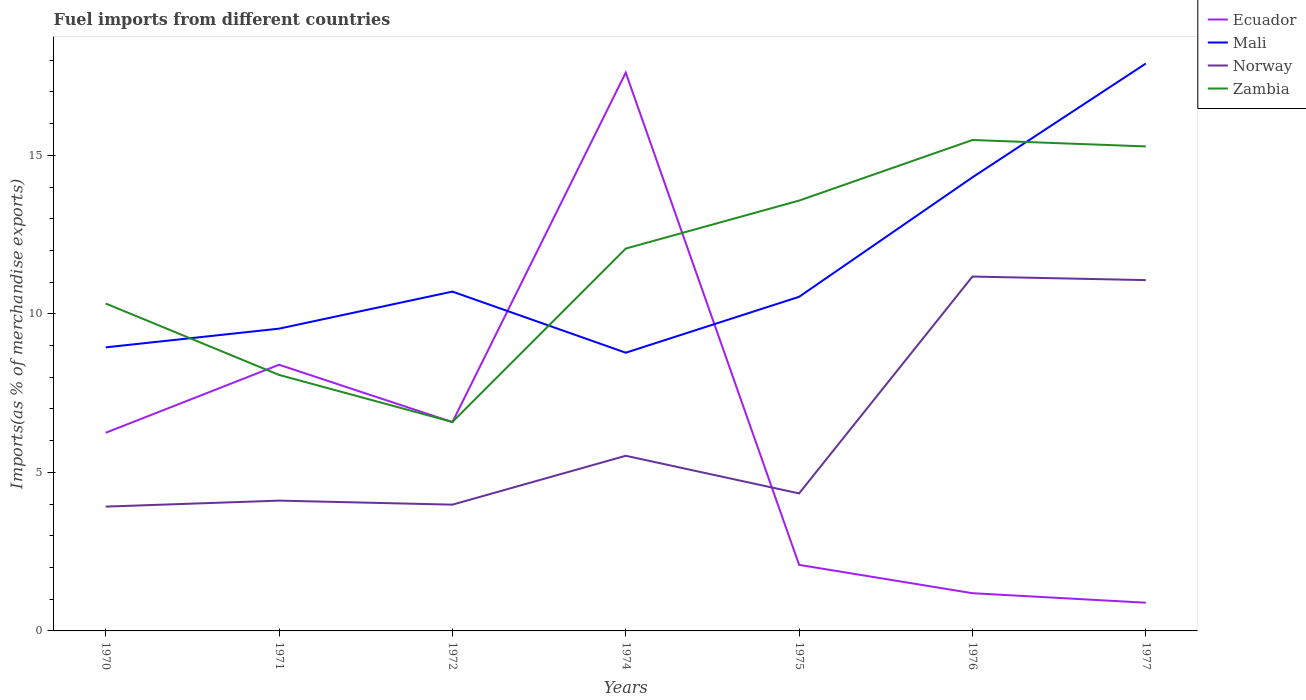Does the line corresponding to Ecuador intersect with the line corresponding to Norway?
Provide a short and direct response. Yes. Is the number of lines equal to the number of legend labels?
Offer a terse response. Yes. Across all years, what is the maximum percentage of imports to different countries in Mali?
Provide a succinct answer. 8.78. In which year was the percentage of imports to different countries in Norway maximum?
Provide a short and direct response. 1970. What is the total percentage of imports to different countries in Norway in the graph?
Offer a very short reply. -6.73. What is the difference between the highest and the second highest percentage of imports to different countries in Mali?
Keep it short and to the point. 9.12. What is the difference between the highest and the lowest percentage of imports to different countries in Norway?
Provide a short and direct response. 2. Are the values on the major ticks of Y-axis written in scientific E-notation?
Keep it short and to the point. No. Does the graph contain grids?
Keep it short and to the point. No. Where does the legend appear in the graph?
Make the answer very short. Top right. How many legend labels are there?
Keep it short and to the point. 4. What is the title of the graph?
Your answer should be very brief. Fuel imports from different countries. Does "Bangladesh" appear as one of the legend labels in the graph?
Make the answer very short. No. What is the label or title of the X-axis?
Provide a short and direct response. Years. What is the label or title of the Y-axis?
Provide a short and direct response. Imports(as % of merchandise exports). What is the Imports(as % of merchandise exports) in Ecuador in 1970?
Your answer should be very brief. 6.25. What is the Imports(as % of merchandise exports) of Mali in 1970?
Your response must be concise. 8.94. What is the Imports(as % of merchandise exports) in Norway in 1970?
Keep it short and to the point. 3.92. What is the Imports(as % of merchandise exports) of Zambia in 1970?
Provide a short and direct response. 10.33. What is the Imports(as % of merchandise exports) of Ecuador in 1971?
Your answer should be very brief. 8.4. What is the Imports(as % of merchandise exports) of Mali in 1971?
Offer a terse response. 9.53. What is the Imports(as % of merchandise exports) of Norway in 1971?
Your response must be concise. 4.11. What is the Imports(as % of merchandise exports) in Zambia in 1971?
Offer a terse response. 8.07. What is the Imports(as % of merchandise exports) in Ecuador in 1972?
Ensure brevity in your answer.  6.59. What is the Imports(as % of merchandise exports) of Mali in 1972?
Give a very brief answer. 10.7. What is the Imports(as % of merchandise exports) of Norway in 1972?
Provide a succinct answer. 3.98. What is the Imports(as % of merchandise exports) in Zambia in 1972?
Your response must be concise. 6.59. What is the Imports(as % of merchandise exports) in Ecuador in 1974?
Make the answer very short. 17.61. What is the Imports(as % of merchandise exports) in Mali in 1974?
Offer a very short reply. 8.78. What is the Imports(as % of merchandise exports) of Norway in 1974?
Offer a very short reply. 5.52. What is the Imports(as % of merchandise exports) of Zambia in 1974?
Ensure brevity in your answer.  12.06. What is the Imports(as % of merchandise exports) of Ecuador in 1975?
Provide a short and direct response. 2.08. What is the Imports(as % of merchandise exports) of Mali in 1975?
Give a very brief answer. 10.54. What is the Imports(as % of merchandise exports) of Norway in 1975?
Ensure brevity in your answer.  4.34. What is the Imports(as % of merchandise exports) in Zambia in 1975?
Provide a succinct answer. 13.57. What is the Imports(as % of merchandise exports) of Ecuador in 1976?
Make the answer very short. 1.19. What is the Imports(as % of merchandise exports) in Mali in 1976?
Offer a very short reply. 14.31. What is the Imports(as % of merchandise exports) of Norway in 1976?
Provide a short and direct response. 11.18. What is the Imports(as % of merchandise exports) of Zambia in 1976?
Ensure brevity in your answer.  15.48. What is the Imports(as % of merchandise exports) in Ecuador in 1977?
Your answer should be compact. 0.89. What is the Imports(as % of merchandise exports) of Mali in 1977?
Provide a succinct answer. 17.9. What is the Imports(as % of merchandise exports) of Norway in 1977?
Provide a succinct answer. 11.06. What is the Imports(as % of merchandise exports) of Zambia in 1977?
Your answer should be compact. 15.28. Across all years, what is the maximum Imports(as % of merchandise exports) in Ecuador?
Your answer should be compact. 17.61. Across all years, what is the maximum Imports(as % of merchandise exports) of Mali?
Give a very brief answer. 17.9. Across all years, what is the maximum Imports(as % of merchandise exports) of Norway?
Give a very brief answer. 11.18. Across all years, what is the maximum Imports(as % of merchandise exports) in Zambia?
Your answer should be compact. 15.48. Across all years, what is the minimum Imports(as % of merchandise exports) in Ecuador?
Keep it short and to the point. 0.89. Across all years, what is the minimum Imports(as % of merchandise exports) in Mali?
Give a very brief answer. 8.78. Across all years, what is the minimum Imports(as % of merchandise exports) in Norway?
Your answer should be compact. 3.92. Across all years, what is the minimum Imports(as % of merchandise exports) of Zambia?
Ensure brevity in your answer.  6.59. What is the total Imports(as % of merchandise exports) of Ecuador in the graph?
Your answer should be very brief. 43. What is the total Imports(as % of merchandise exports) in Mali in the graph?
Provide a succinct answer. 80.7. What is the total Imports(as % of merchandise exports) in Norway in the graph?
Provide a succinct answer. 44.12. What is the total Imports(as % of merchandise exports) of Zambia in the graph?
Offer a very short reply. 81.39. What is the difference between the Imports(as % of merchandise exports) of Ecuador in 1970 and that in 1971?
Provide a succinct answer. -2.15. What is the difference between the Imports(as % of merchandise exports) of Mali in 1970 and that in 1971?
Offer a terse response. -0.59. What is the difference between the Imports(as % of merchandise exports) of Norway in 1970 and that in 1971?
Offer a very short reply. -0.19. What is the difference between the Imports(as % of merchandise exports) of Zambia in 1970 and that in 1971?
Your answer should be compact. 2.25. What is the difference between the Imports(as % of merchandise exports) in Ecuador in 1970 and that in 1972?
Keep it short and to the point. -0.34. What is the difference between the Imports(as % of merchandise exports) in Mali in 1970 and that in 1972?
Provide a short and direct response. -1.76. What is the difference between the Imports(as % of merchandise exports) of Norway in 1970 and that in 1972?
Provide a succinct answer. -0.06. What is the difference between the Imports(as % of merchandise exports) in Zambia in 1970 and that in 1972?
Offer a very short reply. 3.74. What is the difference between the Imports(as % of merchandise exports) in Ecuador in 1970 and that in 1974?
Your response must be concise. -11.36. What is the difference between the Imports(as % of merchandise exports) of Mali in 1970 and that in 1974?
Your answer should be compact. 0.17. What is the difference between the Imports(as % of merchandise exports) in Norway in 1970 and that in 1974?
Make the answer very short. -1.6. What is the difference between the Imports(as % of merchandise exports) in Zambia in 1970 and that in 1974?
Offer a very short reply. -1.73. What is the difference between the Imports(as % of merchandise exports) of Ecuador in 1970 and that in 1975?
Ensure brevity in your answer.  4.17. What is the difference between the Imports(as % of merchandise exports) in Mali in 1970 and that in 1975?
Your answer should be compact. -1.59. What is the difference between the Imports(as % of merchandise exports) in Norway in 1970 and that in 1975?
Your answer should be compact. -0.42. What is the difference between the Imports(as % of merchandise exports) of Zambia in 1970 and that in 1975?
Give a very brief answer. -3.25. What is the difference between the Imports(as % of merchandise exports) of Ecuador in 1970 and that in 1976?
Give a very brief answer. 5.06. What is the difference between the Imports(as % of merchandise exports) in Mali in 1970 and that in 1976?
Provide a succinct answer. -5.36. What is the difference between the Imports(as % of merchandise exports) of Norway in 1970 and that in 1976?
Give a very brief answer. -7.26. What is the difference between the Imports(as % of merchandise exports) of Zambia in 1970 and that in 1976?
Your response must be concise. -5.16. What is the difference between the Imports(as % of merchandise exports) of Ecuador in 1970 and that in 1977?
Your answer should be very brief. 5.36. What is the difference between the Imports(as % of merchandise exports) of Mali in 1970 and that in 1977?
Your answer should be very brief. -8.95. What is the difference between the Imports(as % of merchandise exports) of Norway in 1970 and that in 1977?
Your answer should be compact. -7.14. What is the difference between the Imports(as % of merchandise exports) of Zambia in 1970 and that in 1977?
Give a very brief answer. -4.96. What is the difference between the Imports(as % of merchandise exports) of Ecuador in 1971 and that in 1972?
Keep it short and to the point. 1.81. What is the difference between the Imports(as % of merchandise exports) in Mali in 1971 and that in 1972?
Give a very brief answer. -1.17. What is the difference between the Imports(as % of merchandise exports) of Norway in 1971 and that in 1972?
Your answer should be compact. 0.13. What is the difference between the Imports(as % of merchandise exports) of Zambia in 1971 and that in 1972?
Ensure brevity in your answer.  1.48. What is the difference between the Imports(as % of merchandise exports) of Ecuador in 1971 and that in 1974?
Provide a succinct answer. -9.21. What is the difference between the Imports(as % of merchandise exports) of Mali in 1971 and that in 1974?
Give a very brief answer. 0.76. What is the difference between the Imports(as % of merchandise exports) in Norway in 1971 and that in 1974?
Your answer should be very brief. -1.41. What is the difference between the Imports(as % of merchandise exports) in Zambia in 1971 and that in 1974?
Keep it short and to the point. -3.98. What is the difference between the Imports(as % of merchandise exports) in Ecuador in 1971 and that in 1975?
Your answer should be very brief. 6.31. What is the difference between the Imports(as % of merchandise exports) in Mali in 1971 and that in 1975?
Your answer should be compact. -1. What is the difference between the Imports(as % of merchandise exports) of Norway in 1971 and that in 1975?
Provide a short and direct response. -0.23. What is the difference between the Imports(as % of merchandise exports) of Zambia in 1971 and that in 1975?
Offer a terse response. -5.5. What is the difference between the Imports(as % of merchandise exports) of Ecuador in 1971 and that in 1976?
Your answer should be very brief. 7.21. What is the difference between the Imports(as % of merchandise exports) in Mali in 1971 and that in 1976?
Provide a short and direct response. -4.77. What is the difference between the Imports(as % of merchandise exports) of Norway in 1971 and that in 1976?
Provide a short and direct response. -7.07. What is the difference between the Imports(as % of merchandise exports) of Zambia in 1971 and that in 1976?
Your answer should be compact. -7.41. What is the difference between the Imports(as % of merchandise exports) of Ecuador in 1971 and that in 1977?
Offer a terse response. 7.51. What is the difference between the Imports(as % of merchandise exports) of Mali in 1971 and that in 1977?
Make the answer very short. -8.36. What is the difference between the Imports(as % of merchandise exports) of Norway in 1971 and that in 1977?
Offer a very short reply. -6.96. What is the difference between the Imports(as % of merchandise exports) in Zambia in 1971 and that in 1977?
Your answer should be compact. -7.21. What is the difference between the Imports(as % of merchandise exports) of Ecuador in 1972 and that in 1974?
Make the answer very short. -11.02. What is the difference between the Imports(as % of merchandise exports) of Mali in 1972 and that in 1974?
Your answer should be compact. 1.93. What is the difference between the Imports(as % of merchandise exports) of Norway in 1972 and that in 1974?
Your answer should be very brief. -1.54. What is the difference between the Imports(as % of merchandise exports) in Zambia in 1972 and that in 1974?
Make the answer very short. -5.47. What is the difference between the Imports(as % of merchandise exports) in Ecuador in 1972 and that in 1975?
Your answer should be very brief. 4.5. What is the difference between the Imports(as % of merchandise exports) in Mali in 1972 and that in 1975?
Your response must be concise. 0.17. What is the difference between the Imports(as % of merchandise exports) of Norway in 1972 and that in 1975?
Your response must be concise. -0.35. What is the difference between the Imports(as % of merchandise exports) of Zambia in 1972 and that in 1975?
Ensure brevity in your answer.  -6.98. What is the difference between the Imports(as % of merchandise exports) of Ecuador in 1972 and that in 1976?
Ensure brevity in your answer.  5.4. What is the difference between the Imports(as % of merchandise exports) of Mali in 1972 and that in 1976?
Provide a short and direct response. -3.6. What is the difference between the Imports(as % of merchandise exports) of Norway in 1972 and that in 1976?
Give a very brief answer. -7.2. What is the difference between the Imports(as % of merchandise exports) in Zambia in 1972 and that in 1976?
Provide a succinct answer. -8.89. What is the difference between the Imports(as % of merchandise exports) in Ecuador in 1972 and that in 1977?
Your response must be concise. 5.7. What is the difference between the Imports(as % of merchandise exports) in Mali in 1972 and that in 1977?
Ensure brevity in your answer.  -7.19. What is the difference between the Imports(as % of merchandise exports) of Norway in 1972 and that in 1977?
Ensure brevity in your answer.  -7.08. What is the difference between the Imports(as % of merchandise exports) in Zambia in 1972 and that in 1977?
Your answer should be very brief. -8.69. What is the difference between the Imports(as % of merchandise exports) in Ecuador in 1974 and that in 1975?
Keep it short and to the point. 15.53. What is the difference between the Imports(as % of merchandise exports) in Mali in 1974 and that in 1975?
Your answer should be very brief. -1.76. What is the difference between the Imports(as % of merchandise exports) of Norway in 1974 and that in 1975?
Offer a terse response. 1.19. What is the difference between the Imports(as % of merchandise exports) in Zambia in 1974 and that in 1975?
Your answer should be very brief. -1.51. What is the difference between the Imports(as % of merchandise exports) of Ecuador in 1974 and that in 1976?
Make the answer very short. 16.42. What is the difference between the Imports(as % of merchandise exports) in Mali in 1974 and that in 1976?
Your answer should be very brief. -5.53. What is the difference between the Imports(as % of merchandise exports) of Norway in 1974 and that in 1976?
Provide a short and direct response. -5.65. What is the difference between the Imports(as % of merchandise exports) in Zambia in 1974 and that in 1976?
Ensure brevity in your answer.  -3.42. What is the difference between the Imports(as % of merchandise exports) of Ecuador in 1974 and that in 1977?
Give a very brief answer. 16.72. What is the difference between the Imports(as % of merchandise exports) of Mali in 1974 and that in 1977?
Offer a terse response. -9.12. What is the difference between the Imports(as % of merchandise exports) in Norway in 1974 and that in 1977?
Keep it short and to the point. -5.54. What is the difference between the Imports(as % of merchandise exports) in Zambia in 1974 and that in 1977?
Offer a terse response. -3.22. What is the difference between the Imports(as % of merchandise exports) in Ecuador in 1975 and that in 1976?
Make the answer very short. 0.89. What is the difference between the Imports(as % of merchandise exports) in Mali in 1975 and that in 1976?
Provide a short and direct response. -3.77. What is the difference between the Imports(as % of merchandise exports) in Norway in 1975 and that in 1976?
Offer a very short reply. -6.84. What is the difference between the Imports(as % of merchandise exports) of Zambia in 1975 and that in 1976?
Offer a very short reply. -1.91. What is the difference between the Imports(as % of merchandise exports) in Ecuador in 1975 and that in 1977?
Your answer should be very brief. 1.19. What is the difference between the Imports(as % of merchandise exports) in Mali in 1975 and that in 1977?
Your response must be concise. -7.36. What is the difference between the Imports(as % of merchandise exports) of Norway in 1975 and that in 1977?
Provide a short and direct response. -6.73. What is the difference between the Imports(as % of merchandise exports) of Zambia in 1975 and that in 1977?
Provide a succinct answer. -1.71. What is the difference between the Imports(as % of merchandise exports) in Ecuador in 1976 and that in 1977?
Your answer should be compact. 0.3. What is the difference between the Imports(as % of merchandise exports) in Mali in 1976 and that in 1977?
Offer a very short reply. -3.59. What is the difference between the Imports(as % of merchandise exports) of Norway in 1976 and that in 1977?
Your answer should be very brief. 0.11. What is the difference between the Imports(as % of merchandise exports) of Zambia in 1976 and that in 1977?
Offer a terse response. 0.2. What is the difference between the Imports(as % of merchandise exports) in Ecuador in 1970 and the Imports(as % of merchandise exports) in Mali in 1971?
Provide a succinct answer. -3.28. What is the difference between the Imports(as % of merchandise exports) of Ecuador in 1970 and the Imports(as % of merchandise exports) of Norway in 1971?
Provide a succinct answer. 2.14. What is the difference between the Imports(as % of merchandise exports) of Ecuador in 1970 and the Imports(as % of merchandise exports) of Zambia in 1971?
Keep it short and to the point. -1.82. What is the difference between the Imports(as % of merchandise exports) of Mali in 1970 and the Imports(as % of merchandise exports) of Norway in 1971?
Your response must be concise. 4.83. What is the difference between the Imports(as % of merchandise exports) in Mali in 1970 and the Imports(as % of merchandise exports) in Zambia in 1971?
Offer a very short reply. 0.87. What is the difference between the Imports(as % of merchandise exports) of Norway in 1970 and the Imports(as % of merchandise exports) of Zambia in 1971?
Keep it short and to the point. -4.15. What is the difference between the Imports(as % of merchandise exports) of Ecuador in 1970 and the Imports(as % of merchandise exports) of Mali in 1972?
Offer a very short reply. -4.45. What is the difference between the Imports(as % of merchandise exports) of Ecuador in 1970 and the Imports(as % of merchandise exports) of Norway in 1972?
Make the answer very short. 2.27. What is the difference between the Imports(as % of merchandise exports) of Ecuador in 1970 and the Imports(as % of merchandise exports) of Zambia in 1972?
Provide a succinct answer. -0.34. What is the difference between the Imports(as % of merchandise exports) in Mali in 1970 and the Imports(as % of merchandise exports) in Norway in 1972?
Make the answer very short. 4.96. What is the difference between the Imports(as % of merchandise exports) in Mali in 1970 and the Imports(as % of merchandise exports) in Zambia in 1972?
Make the answer very short. 2.35. What is the difference between the Imports(as % of merchandise exports) in Norway in 1970 and the Imports(as % of merchandise exports) in Zambia in 1972?
Give a very brief answer. -2.67. What is the difference between the Imports(as % of merchandise exports) of Ecuador in 1970 and the Imports(as % of merchandise exports) of Mali in 1974?
Offer a very short reply. -2.52. What is the difference between the Imports(as % of merchandise exports) of Ecuador in 1970 and the Imports(as % of merchandise exports) of Norway in 1974?
Make the answer very short. 0.73. What is the difference between the Imports(as % of merchandise exports) of Ecuador in 1970 and the Imports(as % of merchandise exports) of Zambia in 1974?
Your answer should be compact. -5.81. What is the difference between the Imports(as % of merchandise exports) of Mali in 1970 and the Imports(as % of merchandise exports) of Norway in 1974?
Keep it short and to the point. 3.42. What is the difference between the Imports(as % of merchandise exports) of Mali in 1970 and the Imports(as % of merchandise exports) of Zambia in 1974?
Offer a terse response. -3.12. What is the difference between the Imports(as % of merchandise exports) in Norway in 1970 and the Imports(as % of merchandise exports) in Zambia in 1974?
Your answer should be very brief. -8.14. What is the difference between the Imports(as % of merchandise exports) in Ecuador in 1970 and the Imports(as % of merchandise exports) in Mali in 1975?
Provide a succinct answer. -4.29. What is the difference between the Imports(as % of merchandise exports) in Ecuador in 1970 and the Imports(as % of merchandise exports) in Norway in 1975?
Provide a short and direct response. 1.91. What is the difference between the Imports(as % of merchandise exports) in Ecuador in 1970 and the Imports(as % of merchandise exports) in Zambia in 1975?
Keep it short and to the point. -7.32. What is the difference between the Imports(as % of merchandise exports) of Mali in 1970 and the Imports(as % of merchandise exports) of Norway in 1975?
Make the answer very short. 4.61. What is the difference between the Imports(as % of merchandise exports) of Mali in 1970 and the Imports(as % of merchandise exports) of Zambia in 1975?
Ensure brevity in your answer.  -4.63. What is the difference between the Imports(as % of merchandise exports) of Norway in 1970 and the Imports(as % of merchandise exports) of Zambia in 1975?
Provide a short and direct response. -9.65. What is the difference between the Imports(as % of merchandise exports) of Ecuador in 1970 and the Imports(as % of merchandise exports) of Mali in 1976?
Give a very brief answer. -8.06. What is the difference between the Imports(as % of merchandise exports) in Ecuador in 1970 and the Imports(as % of merchandise exports) in Norway in 1976?
Your response must be concise. -4.93. What is the difference between the Imports(as % of merchandise exports) in Ecuador in 1970 and the Imports(as % of merchandise exports) in Zambia in 1976?
Keep it short and to the point. -9.23. What is the difference between the Imports(as % of merchandise exports) in Mali in 1970 and the Imports(as % of merchandise exports) in Norway in 1976?
Keep it short and to the point. -2.23. What is the difference between the Imports(as % of merchandise exports) in Mali in 1970 and the Imports(as % of merchandise exports) in Zambia in 1976?
Offer a terse response. -6.54. What is the difference between the Imports(as % of merchandise exports) of Norway in 1970 and the Imports(as % of merchandise exports) of Zambia in 1976?
Your answer should be compact. -11.56. What is the difference between the Imports(as % of merchandise exports) in Ecuador in 1970 and the Imports(as % of merchandise exports) in Mali in 1977?
Your answer should be very brief. -11.65. What is the difference between the Imports(as % of merchandise exports) of Ecuador in 1970 and the Imports(as % of merchandise exports) of Norway in 1977?
Give a very brief answer. -4.81. What is the difference between the Imports(as % of merchandise exports) of Ecuador in 1970 and the Imports(as % of merchandise exports) of Zambia in 1977?
Keep it short and to the point. -9.03. What is the difference between the Imports(as % of merchandise exports) of Mali in 1970 and the Imports(as % of merchandise exports) of Norway in 1977?
Make the answer very short. -2.12. What is the difference between the Imports(as % of merchandise exports) in Mali in 1970 and the Imports(as % of merchandise exports) in Zambia in 1977?
Provide a short and direct response. -6.34. What is the difference between the Imports(as % of merchandise exports) in Norway in 1970 and the Imports(as % of merchandise exports) in Zambia in 1977?
Ensure brevity in your answer.  -11.36. What is the difference between the Imports(as % of merchandise exports) in Ecuador in 1971 and the Imports(as % of merchandise exports) in Mali in 1972?
Provide a succinct answer. -2.31. What is the difference between the Imports(as % of merchandise exports) of Ecuador in 1971 and the Imports(as % of merchandise exports) of Norway in 1972?
Provide a short and direct response. 4.41. What is the difference between the Imports(as % of merchandise exports) in Ecuador in 1971 and the Imports(as % of merchandise exports) in Zambia in 1972?
Provide a short and direct response. 1.81. What is the difference between the Imports(as % of merchandise exports) of Mali in 1971 and the Imports(as % of merchandise exports) of Norway in 1972?
Offer a very short reply. 5.55. What is the difference between the Imports(as % of merchandise exports) of Mali in 1971 and the Imports(as % of merchandise exports) of Zambia in 1972?
Offer a very short reply. 2.94. What is the difference between the Imports(as % of merchandise exports) of Norway in 1971 and the Imports(as % of merchandise exports) of Zambia in 1972?
Your response must be concise. -2.48. What is the difference between the Imports(as % of merchandise exports) of Ecuador in 1971 and the Imports(as % of merchandise exports) of Mali in 1974?
Provide a succinct answer. -0.38. What is the difference between the Imports(as % of merchandise exports) in Ecuador in 1971 and the Imports(as % of merchandise exports) in Norway in 1974?
Offer a terse response. 2.87. What is the difference between the Imports(as % of merchandise exports) of Ecuador in 1971 and the Imports(as % of merchandise exports) of Zambia in 1974?
Your answer should be compact. -3.66. What is the difference between the Imports(as % of merchandise exports) of Mali in 1971 and the Imports(as % of merchandise exports) of Norway in 1974?
Give a very brief answer. 4.01. What is the difference between the Imports(as % of merchandise exports) of Mali in 1971 and the Imports(as % of merchandise exports) of Zambia in 1974?
Give a very brief answer. -2.53. What is the difference between the Imports(as % of merchandise exports) of Norway in 1971 and the Imports(as % of merchandise exports) of Zambia in 1974?
Your answer should be compact. -7.95. What is the difference between the Imports(as % of merchandise exports) in Ecuador in 1971 and the Imports(as % of merchandise exports) in Mali in 1975?
Your response must be concise. -2.14. What is the difference between the Imports(as % of merchandise exports) in Ecuador in 1971 and the Imports(as % of merchandise exports) in Norway in 1975?
Give a very brief answer. 4.06. What is the difference between the Imports(as % of merchandise exports) of Ecuador in 1971 and the Imports(as % of merchandise exports) of Zambia in 1975?
Your answer should be compact. -5.18. What is the difference between the Imports(as % of merchandise exports) of Mali in 1971 and the Imports(as % of merchandise exports) of Norway in 1975?
Your answer should be very brief. 5.2. What is the difference between the Imports(as % of merchandise exports) in Mali in 1971 and the Imports(as % of merchandise exports) in Zambia in 1975?
Offer a terse response. -4.04. What is the difference between the Imports(as % of merchandise exports) in Norway in 1971 and the Imports(as % of merchandise exports) in Zambia in 1975?
Provide a short and direct response. -9.46. What is the difference between the Imports(as % of merchandise exports) of Ecuador in 1971 and the Imports(as % of merchandise exports) of Mali in 1976?
Offer a very short reply. -5.91. What is the difference between the Imports(as % of merchandise exports) in Ecuador in 1971 and the Imports(as % of merchandise exports) in Norway in 1976?
Provide a succinct answer. -2.78. What is the difference between the Imports(as % of merchandise exports) of Ecuador in 1971 and the Imports(as % of merchandise exports) of Zambia in 1976?
Your response must be concise. -7.09. What is the difference between the Imports(as % of merchandise exports) of Mali in 1971 and the Imports(as % of merchandise exports) of Norway in 1976?
Ensure brevity in your answer.  -1.64. What is the difference between the Imports(as % of merchandise exports) in Mali in 1971 and the Imports(as % of merchandise exports) in Zambia in 1976?
Make the answer very short. -5.95. What is the difference between the Imports(as % of merchandise exports) of Norway in 1971 and the Imports(as % of merchandise exports) of Zambia in 1976?
Ensure brevity in your answer.  -11.38. What is the difference between the Imports(as % of merchandise exports) in Ecuador in 1971 and the Imports(as % of merchandise exports) in Mali in 1977?
Your response must be concise. -9.5. What is the difference between the Imports(as % of merchandise exports) of Ecuador in 1971 and the Imports(as % of merchandise exports) of Norway in 1977?
Make the answer very short. -2.67. What is the difference between the Imports(as % of merchandise exports) of Ecuador in 1971 and the Imports(as % of merchandise exports) of Zambia in 1977?
Offer a terse response. -6.89. What is the difference between the Imports(as % of merchandise exports) in Mali in 1971 and the Imports(as % of merchandise exports) in Norway in 1977?
Offer a very short reply. -1.53. What is the difference between the Imports(as % of merchandise exports) of Mali in 1971 and the Imports(as % of merchandise exports) of Zambia in 1977?
Provide a short and direct response. -5.75. What is the difference between the Imports(as % of merchandise exports) in Norway in 1971 and the Imports(as % of merchandise exports) in Zambia in 1977?
Keep it short and to the point. -11.17. What is the difference between the Imports(as % of merchandise exports) in Ecuador in 1972 and the Imports(as % of merchandise exports) in Mali in 1974?
Offer a terse response. -2.19. What is the difference between the Imports(as % of merchandise exports) of Ecuador in 1972 and the Imports(as % of merchandise exports) of Norway in 1974?
Give a very brief answer. 1.06. What is the difference between the Imports(as % of merchandise exports) of Ecuador in 1972 and the Imports(as % of merchandise exports) of Zambia in 1974?
Keep it short and to the point. -5.47. What is the difference between the Imports(as % of merchandise exports) of Mali in 1972 and the Imports(as % of merchandise exports) of Norway in 1974?
Make the answer very short. 5.18. What is the difference between the Imports(as % of merchandise exports) in Mali in 1972 and the Imports(as % of merchandise exports) in Zambia in 1974?
Offer a terse response. -1.36. What is the difference between the Imports(as % of merchandise exports) of Norway in 1972 and the Imports(as % of merchandise exports) of Zambia in 1974?
Ensure brevity in your answer.  -8.08. What is the difference between the Imports(as % of merchandise exports) of Ecuador in 1972 and the Imports(as % of merchandise exports) of Mali in 1975?
Keep it short and to the point. -3.95. What is the difference between the Imports(as % of merchandise exports) in Ecuador in 1972 and the Imports(as % of merchandise exports) in Norway in 1975?
Offer a terse response. 2.25. What is the difference between the Imports(as % of merchandise exports) of Ecuador in 1972 and the Imports(as % of merchandise exports) of Zambia in 1975?
Keep it short and to the point. -6.99. What is the difference between the Imports(as % of merchandise exports) in Mali in 1972 and the Imports(as % of merchandise exports) in Norway in 1975?
Offer a very short reply. 6.37. What is the difference between the Imports(as % of merchandise exports) in Mali in 1972 and the Imports(as % of merchandise exports) in Zambia in 1975?
Your answer should be very brief. -2.87. What is the difference between the Imports(as % of merchandise exports) in Norway in 1972 and the Imports(as % of merchandise exports) in Zambia in 1975?
Provide a succinct answer. -9.59. What is the difference between the Imports(as % of merchandise exports) of Ecuador in 1972 and the Imports(as % of merchandise exports) of Mali in 1976?
Provide a short and direct response. -7.72. What is the difference between the Imports(as % of merchandise exports) in Ecuador in 1972 and the Imports(as % of merchandise exports) in Norway in 1976?
Make the answer very short. -4.59. What is the difference between the Imports(as % of merchandise exports) of Ecuador in 1972 and the Imports(as % of merchandise exports) of Zambia in 1976?
Offer a very short reply. -8.9. What is the difference between the Imports(as % of merchandise exports) of Mali in 1972 and the Imports(as % of merchandise exports) of Norway in 1976?
Provide a succinct answer. -0.47. What is the difference between the Imports(as % of merchandise exports) of Mali in 1972 and the Imports(as % of merchandise exports) of Zambia in 1976?
Your answer should be very brief. -4.78. What is the difference between the Imports(as % of merchandise exports) in Norway in 1972 and the Imports(as % of merchandise exports) in Zambia in 1976?
Your answer should be compact. -11.5. What is the difference between the Imports(as % of merchandise exports) of Ecuador in 1972 and the Imports(as % of merchandise exports) of Mali in 1977?
Make the answer very short. -11.31. What is the difference between the Imports(as % of merchandise exports) in Ecuador in 1972 and the Imports(as % of merchandise exports) in Norway in 1977?
Offer a very short reply. -4.48. What is the difference between the Imports(as % of merchandise exports) of Ecuador in 1972 and the Imports(as % of merchandise exports) of Zambia in 1977?
Give a very brief answer. -8.7. What is the difference between the Imports(as % of merchandise exports) in Mali in 1972 and the Imports(as % of merchandise exports) in Norway in 1977?
Your answer should be compact. -0.36. What is the difference between the Imports(as % of merchandise exports) in Mali in 1972 and the Imports(as % of merchandise exports) in Zambia in 1977?
Ensure brevity in your answer.  -4.58. What is the difference between the Imports(as % of merchandise exports) of Norway in 1972 and the Imports(as % of merchandise exports) of Zambia in 1977?
Keep it short and to the point. -11.3. What is the difference between the Imports(as % of merchandise exports) in Ecuador in 1974 and the Imports(as % of merchandise exports) in Mali in 1975?
Your answer should be very brief. 7.07. What is the difference between the Imports(as % of merchandise exports) in Ecuador in 1974 and the Imports(as % of merchandise exports) in Norway in 1975?
Offer a terse response. 13.27. What is the difference between the Imports(as % of merchandise exports) in Ecuador in 1974 and the Imports(as % of merchandise exports) in Zambia in 1975?
Offer a very short reply. 4.04. What is the difference between the Imports(as % of merchandise exports) in Mali in 1974 and the Imports(as % of merchandise exports) in Norway in 1975?
Offer a very short reply. 4.44. What is the difference between the Imports(as % of merchandise exports) of Mali in 1974 and the Imports(as % of merchandise exports) of Zambia in 1975?
Your response must be concise. -4.8. What is the difference between the Imports(as % of merchandise exports) of Norway in 1974 and the Imports(as % of merchandise exports) of Zambia in 1975?
Keep it short and to the point. -8.05. What is the difference between the Imports(as % of merchandise exports) of Ecuador in 1974 and the Imports(as % of merchandise exports) of Mali in 1976?
Give a very brief answer. 3.3. What is the difference between the Imports(as % of merchandise exports) in Ecuador in 1974 and the Imports(as % of merchandise exports) in Norway in 1976?
Your response must be concise. 6.43. What is the difference between the Imports(as % of merchandise exports) of Ecuador in 1974 and the Imports(as % of merchandise exports) of Zambia in 1976?
Your answer should be very brief. 2.12. What is the difference between the Imports(as % of merchandise exports) of Mali in 1974 and the Imports(as % of merchandise exports) of Norway in 1976?
Keep it short and to the point. -2.4. What is the difference between the Imports(as % of merchandise exports) in Mali in 1974 and the Imports(as % of merchandise exports) in Zambia in 1976?
Make the answer very short. -6.71. What is the difference between the Imports(as % of merchandise exports) in Norway in 1974 and the Imports(as % of merchandise exports) in Zambia in 1976?
Ensure brevity in your answer.  -9.96. What is the difference between the Imports(as % of merchandise exports) in Ecuador in 1974 and the Imports(as % of merchandise exports) in Mali in 1977?
Offer a very short reply. -0.29. What is the difference between the Imports(as % of merchandise exports) of Ecuador in 1974 and the Imports(as % of merchandise exports) of Norway in 1977?
Provide a short and direct response. 6.54. What is the difference between the Imports(as % of merchandise exports) of Ecuador in 1974 and the Imports(as % of merchandise exports) of Zambia in 1977?
Ensure brevity in your answer.  2.33. What is the difference between the Imports(as % of merchandise exports) of Mali in 1974 and the Imports(as % of merchandise exports) of Norway in 1977?
Provide a short and direct response. -2.29. What is the difference between the Imports(as % of merchandise exports) of Mali in 1974 and the Imports(as % of merchandise exports) of Zambia in 1977?
Ensure brevity in your answer.  -6.51. What is the difference between the Imports(as % of merchandise exports) of Norway in 1974 and the Imports(as % of merchandise exports) of Zambia in 1977?
Your answer should be compact. -9.76. What is the difference between the Imports(as % of merchandise exports) in Ecuador in 1975 and the Imports(as % of merchandise exports) in Mali in 1976?
Keep it short and to the point. -12.22. What is the difference between the Imports(as % of merchandise exports) of Ecuador in 1975 and the Imports(as % of merchandise exports) of Norway in 1976?
Give a very brief answer. -9.09. What is the difference between the Imports(as % of merchandise exports) in Ecuador in 1975 and the Imports(as % of merchandise exports) in Zambia in 1976?
Offer a terse response. -13.4. What is the difference between the Imports(as % of merchandise exports) in Mali in 1975 and the Imports(as % of merchandise exports) in Norway in 1976?
Give a very brief answer. -0.64. What is the difference between the Imports(as % of merchandise exports) in Mali in 1975 and the Imports(as % of merchandise exports) in Zambia in 1976?
Your answer should be compact. -4.95. What is the difference between the Imports(as % of merchandise exports) of Norway in 1975 and the Imports(as % of merchandise exports) of Zambia in 1976?
Keep it short and to the point. -11.15. What is the difference between the Imports(as % of merchandise exports) in Ecuador in 1975 and the Imports(as % of merchandise exports) in Mali in 1977?
Make the answer very short. -15.81. What is the difference between the Imports(as % of merchandise exports) of Ecuador in 1975 and the Imports(as % of merchandise exports) of Norway in 1977?
Provide a short and direct response. -8.98. What is the difference between the Imports(as % of merchandise exports) in Ecuador in 1975 and the Imports(as % of merchandise exports) in Zambia in 1977?
Give a very brief answer. -13.2. What is the difference between the Imports(as % of merchandise exports) of Mali in 1975 and the Imports(as % of merchandise exports) of Norway in 1977?
Provide a short and direct response. -0.53. What is the difference between the Imports(as % of merchandise exports) in Mali in 1975 and the Imports(as % of merchandise exports) in Zambia in 1977?
Your answer should be very brief. -4.74. What is the difference between the Imports(as % of merchandise exports) of Norway in 1975 and the Imports(as % of merchandise exports) of Zambia in 1977?
Your answer should be compact. -10.94. What is the difference between the Imports(as % of merchandise exports) in Ecuador in 1976 and the Imports(as % of merchandise exports) in Mali in 1977?
Offer a terse response. -16.71. What is the difference between the Imports(as % of merchandise exports) in Ecuador in 1976 and the Imports(as % of merchandise exports) in Norway in 1977?
Ensure brevity in your answer.  -9.88. What is the difference between the Imports(as % of merchandise exports) in Ecuador in 1976 and the Imports(as % of merchandise exports) in Zambia in 1977?
Your answer should be compact. -14.09. What is the difference between the Imports(as % of merchandise exports) of Mali in 1976 and the Imports(as % of merchandise exports) of Norway in 1977?
Keep it short and to the point. 3.24. What is the difference between the Imports(as % of merchandise exports) of Mali in 1976 and the Imports(as % of merchandise exports) of Zambia in 1977?
Offer a very short reply. -0.97. What is the difference between the Imports(as % of merchandise exports) of Norway in 1976 and the Imports(as % of merchandise exports) of Zambia in 1977?
Provide a succinct answer. -4.1. What is the average Imports(as % of merchandise exports) in Ecuador per year?
Your answer should be very brief. 6.14. What is the average Imports(as % of merchandise exports) of Mali per year?
Offer a very short reply. 11.53. What is the average Imports(as % of merchandise exports) of Norway per year?
Your response must be concise. 6.3. What is the average Imports(as % of merchandise exports) in Zambia per year?
Ensure brevity in your answer.  11.63. In the year 1970, what is the difference between the Imports(as % of merchandise exports) of Ecuador and Imports(as % of merchandise exports) of Mali?
Your answer should be very brief. -2.69. In the year 1970, what is the difference between the Imports(as % of merchandise exports) in Ecuador and Imports(as % of merchandise exports) in Norway?
Provide a short and direct response. 2.33. In the year 1970, what is the difference between the Imports(as % of merchandise exports) in Ecuador and Imports(as % of merchandise exports) in Zambia?
Your answer should be compact. -4.08. In the year 1970, what is the difference between the Imports(as % of merchandise exports) of Mali and Imports(as % of merchandise exports) of Norway?
Your answer should be compact. 5.02. In the year 1970, what is the difference between the Imports(as % of merchandise exports) of Mali and Imports(as % of merchandise exports) of Zambia?
Offer a very short reply. -1.38. In the year 1970, what is the difference between the Imports(as % of merchandise exports) in Norway and Imports(as % of merchandise exports) in Zambia?
Make the answer very short. -6.41. In the year 1971, what is the difference between the Imports(as % of merchandise exports) of Ecuador and Imports(as % of merchandise exports) of Mali?
Make the answer very short. -1.14. In the year 1971, what is the difference between the Imports(as % of merchandise exports) of Ecuador and Imports(as % of merchandise exports) of Norway?
Your answer should be compact. 4.29. In the year 1971, what is the difference between the Imports(as % of merchandise exports) of Ecuador and Imports(as % of merchandise exports) of Zambia?
Ensure brevity in your answer.  0.32. In the year 1971, what is the difference between the Imports(as % of merchandise exports) in Mali and Imports(as % of merchandise exports) in Norway?
Your answer should be compact. 5.42. In the year 1971, what is the difference between the Imports(as % of merchandise exports) in Mali and Imports(as % of merchandise exports) in Zambia?
Keep it short and to the point. 1.46. In the year 1971, what is the difference between the Imports(as % of merchandise exports) of Norway and Imports(as % of merchandise exports) of Zambia?
Your answer should be compact. -3.97. In the year 1972, what is the difference between the Imports(as % of merchandise exports) in Ecuador and Imports(as % of merchandise exports) in Mali?
Your answer should be very brief. -4.12. In the year 1972, what is the difference between the Imports(as % of merchandise exports) in Ecuador and Imports(as % of merchandise exports) in Norway?
Provide a short and direct response. 2.6. In the year 1972, what is the difference between the Imports(as % of merchandise exports) in Ecuador and Imports(as % of merchandise exports) in Zambia?
Your answer should be very brief. -0.01. In the year 1972, what is the difference between the Imports(as % of merchandise exports) in Mali and Imports(as % of merchandise exports) in Norway?
Your response must be concise. 6.72. In the year 1972, what is the difference between the Imports(as % of merchandise exports) in Mali and Imports(as % of merchandise exports) in Zambia?
Your answer should be compact. 4.11. In the year 1972, what is the difference between the Imports(as % of merchandise exports) of Norway and Imports(as % of merchandise exports) of Zambia?
Offer a very short reply. -2.61. In the year 1974, what is the difference between the Imports(as % of merchandise exports) in Ecuador and Imports(as % of merchandise exports) in Mali?
Your answer should be very brief. 8.83. In the year 1974, what is the difference between the Imports(as % of merchandise exports) in Ecuador and Imports(as % of merchandise exports) in Norway?
Offer a very short reply. 12.08. In the year 1974, what is the difference between the Imports(as % of merchandise exports) in Ecuador and Imports(as % of merchandise exports) in Zambia?
Your answer should be compact. 5.55. In the year 1974, what is the difference between the Imports(as % of merchandise exports) of Mali and Imports(as % of merchandise exports) of Norway?
Your answer should be compact. 3.25. In the year 1974, what is the difference between the Imports(as % of merchandise exports) in Mali and Imports(as % of merchandise exports) in Zambia?
Offer a very short reply. -3.28. In the year 1974, what is the difference between the Imports(as % of merchandise exports) in Norway and Imports(as % of merchandise exports) in Zambia?
Give a very brief answer. -6.54. In the year 1975, what is the difference between the Imports(as % of merchandise exports) of Ecuador and Imports(as % of merchandise exports) of Mali?
Provide a short and direct response. -8.45. In the year 1975, what is the difference between the Imports(as % of merchandise exports) in Ecuador and Imports(as % of merchandise exports) in Norway?
Keep it short and to the point. -2.25. In the year 1975, what is the difference between the Imports(as % of merchandise exports) of Ecuador and Imports(as % of merchandise exports) of Zambia?
Your response must be concise. -11.49. In the year 1975, what is the difference between the Imports(as % of merchandise exports) of Mali and Imports(as % of merchandise exports) of Norway?
Ensure brevity in your answer.  6.2. In the year 1975, what is the difference between the Imports(as % of merchandise exports) of Mali and Imports(as % of merchandise exports) of Zambia?
Your response must be concise. -3.04. In the year 1975, what is the difference between the Imports(as % of merchandise exports) of Norway and Imports(as % of merchandise exports) of Zambia?
Ensure brevity in your answer.  -9.24. In the year 1976, what is the difference between the Imports(as % of merchandise exports) in Ecuador and Imports(as % of merchandise exports) in Mali?
Keep it short and to the point. -13.12. In the year 1976, what is the difference between the Imports(as % of merchandise exports) of Ecuador and Imports(as % of merchandise exports) of Norway?
Give a very brief answer. -9.99. In the year 1976, what is the difference between the Imports(as % of merchandise exports) in Ecuador and Imports(as % of merchandise exports) in Zambia?
Make the answer very short. -14.3. In the year 1976, what is the difference between the Imports(as % of merchandise exports) in Mali and Imports(as % of merchandise exports) in Norway?
Provide a succinct answer. 3.13. In the year 1976, what is the difference between the Imports(as % of merchandise exports) in Mali and Imports(as % of merchandise exports) in Zambia?
Your answer should be compact. -1.18. In the year 1976, what is the difference between the Imports(as % of merchandise exports) of Norway and Imports(as % of merchandise exports) of Zambia?
Give a very brief answer. -4.31. In the year 1977, what is the difference between the Imports(as % of merchandise exports) of Ecuador and Imports(as % of merchandise exports) of Mali?
Offer a terse response. -17.01. In the year 1977, what is the difference between the Imports(as % of merchandise exports) of Ecuador and Imports(as % of merchandise exports) of Norway?
Provide a succinct answer. -10.18. In the year 1977, what is the difference between the Imports(as % of merchandise exports) of Ecuador and Imports(as % of merchandise exports) of Zambia?
Your answer should be very brief. -14.39. In the year 1977, what is the difference between the Imports(as % of merchandise exports) of Mali and Imports(as % of merchandise exports) of Norway?
Offer a very short reply. 6.83. In the year 1977, what is the difference between the Imports(as % of merchandise exports) of Mali and Imports(as % of merchandise exports) of Zambia?
Keep it short and to the point. 2.61. In the year 1977, what is the difference between the Imports(as % of merchandise exports) in Norway and Imports(as % of merchandise exports) in Zambia?
Your answer should be compact. -4.22. What is the ratio of the Imports(as % of merchandise exports) in Ecuador in 1970 to that in 1971?
Make the answer very short. 0.74. What is the ratio of the Imports(as % of merchandise exports) of Mali in 1970 to that in 1971?
Keep it short and to the point. 0.94. What is the ratio of the Imports(as % of merchandise exports) of Norway in 1970 to that in 1971?
Give a very brief answer. 0.95. What is the ratio of the Imports(as % of merchandise exports) of Zambia in 1970 to that in 1971?
Keep it short and to the point. 1.28. What is the ratio of the Imports(as % of merchandise exports) of Ecuador in 1970 to that in 1972?
Your answer should be very brief. 0.95. What is the ratio of the Imports(as % of merchandise exports) in Mali in 1970 to that in 1972?
Keep it short and to the point. 0.84. What is the ratio of the Imports(as % of merchandise exports) of Norway in 1970 to that in 1972?
Make the answer very short. 0.98. What is the ratio of the Imports(as % of merchandise exports) of Zambia in 1970 to that in 1972?
Ensure brevity in your answer.  1.57. What is the ratio of the Imports(as % of merchandise exports) in Ecuador in 1970 to that in 1974?
Keep it short and to the point. 0.35. What is the ratio of the Imports(as % of merchandise exports) in Mali in 1970 to that in 1974?
Offer a terse response. 1.02. What is the ratio of the Imports(as % of merchandise exports) in Norway in 1970 to that in 1974?
Provide a short and direct response. 0.71. What is the ratio of the Imports(as % of merchandise exports) in Zambia in 1970 to that in 1974?
Give a very brief answer. 0.86. What is the ratio of the Imports(as % of merchandise exports) in Mali in 1970 to that in 1975?
Offer a very short reply. 0.85. What is the ratio of the Imports(as % of merchandise exports) of Norway in 1970 to that in 1975?
Your answer should be very brief. 0.9. What is the ratio of the Imports(as % of merchandise exports) in Zambia in 1970 to that in 1975?
Offer a terse response. 0.76. What is the ratio of the Imports(as % of merchandise exports) of Ecuador in 1970 to that in 1976?
Your answer should be very brief. 5.25. What is the ratio of the Imports(as % of merchandise exports) in Mali in 1970 to that in 1976?
Provide a succinct answer. 0.63. What is the ratio of the Imports(as % of merchandise exports) of Norway in 1970 to that in 1976?
Give a very brief answer. 0.35. What is the ratio of the Imports(as % of merchandise exports) of Zambia in 1970 to that in 1976?
Make the answer very short. 0.67. What is the ratio of the Imports(as % of merchandise exports) of Ecuador in 1970 to that in 1977?
Keep it short and to the point. 7.02. What is the ratio of the Imports(as % of merchandise exports) in Mali in 1970 to that in 1977?
Give a very brief answer. 0.5. What is the ratio of the Imports(as % of merchandise exports) of Norway in 1970 to that in 1977?
Keep it short and to the point. 0.35. What is the ratio of the Imports(as % of merchandise exports) in Zambia in 1970 to that in 1977?
Keep it short and to the point. 0.68. What is the ratio of the Imports(as % of merchandise exports) in Ecuador in 1971 to that in 1972?
Offer a very short reply. 1.27. What is the ratio of the Imports(as % of merchandise exports) of Mali in 1971 to that in 1972?
Offer a terse response. 0.89. What is the ratio of the Imports(as % of merchandise exports) of Norway in 1971 to that in 1972?
Your answer should be very brief. 1.03. What is the ratio of the Imports(as % of merchandise exports) of Zambia in 1971 to that in 1972?
Provide a succinct answer. 1.23. What is the ratio of the Imports(as % of merchandise exports) of Ecuador in 1971 to that in 1974?
Offer a terse response. 0.48. What is the ratio of the Imports(as % of merchandise exports) of Mali in 1971 to that in 1974?
Provide a succinct answer. 1.09. What is the ratio of the Imports(as % of merchandise exports) in Norway in 1971 to that in 1974?
Your answer should be compact. 0.74. What is the ratio of the Imports(as % of merchandise exports) of Zambia in 1971 to that in 1974?
Your answer should be compact. 0.67. What is the ratio of the Imports(as % of merchandise exports) in Ecuador in 1971 to that in 1975?
Your answer should be compact. 4.03. What is the ratio of the Imports(as % of merchandise exports) of Mali in 1971 to that in 1975?
Give a very brief answer. 0.9. What is the ratio of the Imports(as % of merchandise exports) in Norway in 1971 to that in 1975?
Your response must be concise. 0.95. What is the ratio of the Imports(as % of merchandise exports) in Zambia in 1971 to that in 1975?
Your response must be concise. 0.59. What is the ratio of the Imports(as % of merchandise exports) of Ecuador in 1971 to that in 1976?
Provide a succinct answer. 7.06. What is the ratio of the Imports(as % of merchandise exports) in Mali in 1971 to that in 1976?
Make the answer very short. 0.67. What is the ratio of the Imports(as % of merchandise exports) in Norway in 1971 to that in 1976?
Your answer should be very brief. 0.37. What is the ratio of the Imports(as % of merchandise exports) in Zambia in 1971 to that in 1976?
Provide a short and direct response. 0.52. What is the ratio of the Imports(as % of merchandise exports) of Ecuador in 1971 to that in 1977?
Offer a very short reply. 9.44. What is the ratio of the Imports(as % of merchandise exports) of Mali in 1971 to that in 1977?
Your response must be concise. 0.53. What is the ratio of the Imports(as % of merchandise exports) in Norway in 1971 to that in 1977?
Make the answer very short. 0.37. What is the ratio of the Imports(as % of merchandise exports) in Zambia in 1971 to that in 1977?
Offer a terse response. 0.53. What is the ratio of the Imports(as % of merchandise exports) of Ecuador in 1972 to that in 1974?
Keep it short and to the point. 0.37. What is the ratio of the Imports(as % of merchandise exports) of Mali in 1972 to that in 1974?
Provide a short and direct response. 1.22. What is the ratio of the Imports(as % of merchandise exports) of Norway in 1972 to that in 1974?
Make the answer very short. 0.72. What is the ratio of the Imports(as % of merchandise exports) in Zambia in 1972 to that in 1974?
Provide a short and direct response. 0.55. What is the ratio of the Imports(as % of merchandise exports) in Ecuador in 1972 to that in 1975?
Offer a very short reply. 3.16. What is the ratio of the Imports(as % of merchandise exports) of Mali in 1972 to that in 1975?
Make the answer very short. 1.02. What is the ratio of the Imports(as % of merchandise exports) in Norway in 1972 to that in 1975?
Your answer should be compact. 0.92. What is the ratio of the Imports(as % of merchandise exports) of Zambia in 1972 to that in 1975?
Make the answer very short. 0.49. What is the ratio of the Imports(as % of merchandise exports) of Ecuador in 1972 to that in 1976?
Offer a terse response. 5.54. What is the ratio of the Imports(as % of merchandise exports) in Mali in 1972 to that in 1976?
Offer a very short reply. 0.75. What is the ratio of the Imports(as % of merchandise exports) in Norway in 1972 to that in 1976?
Give a very brief answer. 0.36. What is the ratio of the Imports(as % of merchandise exports) in Zambia in 1972 to that in 1976?
Make the answer very short. 0.43. What is the ratio of the Imports(as % of merchandise exports) in Ecuador in 1972 to that in 1977?
Give a very brief answer. 7.4. What is the ratio of the Imports(as % of merchandise exports) in Mali in 1972 to that in 1977?
Your answer should be compact. 0.6. What is the ratio of the Imports(as % of merchandise exports) of Norway in 1972 to that in 1977?
Provide a short and direct response. 0.36. What is the ratio of the Imports(as % of merchandise exports) of Zambia in 1972 to that in 1977?
Your response must be concise. 0.43. What is the ratio of the Imports(as % of merchandise exports) of Ecuador in 1974 to that in 1975?
Offer a terse response. 8.45. What is the ratio of the Imports(as % of merchandise exports) of Mali in 1974 to that in 1975?
Give a very brief answer. 0.83. What is the ratio of the Imports(as % of merchandise exports) in Norway in 1974 to that in 1975?
Keep it short and to the point. 1.27. What is the ratio of the Imports(as % of merchandise exports) in Zambia in 1974 to that in 1975?
Your answer should be very brief. 0.89. What is the ratio of the Imports(as % of merchandise exports) in Ecuador in 1974 to that in 1976?
Keep it short and to the point. 14.8. What is the ratio of the Imports(as % of merchandise exports) of Mali in 1974 to that in 1976?
Your answer should be compact. 0.61. What is the ratio of the Imports(as % of merchandise exports) of Norway in 1974 to that in 1976?
Give a very brief answer. 0.49. What is the ratio of the Imports(as % of merchandise exports) in Zambia in 1974 to that in 1976?
Provide a short and direct response. 0.78. What is the ratio of the Imports(as % of merchandise exports) in Ecuador in 1974 to that in 1977?
Provide a short and direct response. 19.79. What is the ratio of the Imports(as % of merchandise exports) of Mali in 1974 to that in 1977?
Ensure brevity in your answer.  0.49. What is the ratio of the Imports(as % of merchandise exports) in Norway in 1974 to that in 1977?
Your response must be concise. 0.5. What is the ratio of the Imports(as % of merchandise exports) in Zambia in 1974 to that in 1977?
Make the answer very short. 0.79. What is the ratio of the Imports(as % of merchandise exports) in Ecuador in 1975 to that in 1976?
Keep it short and to the point. 1.75. What is the ratio of the Imports(as % of merchandise exports) of Mali in 1975 to that in 1976?
Offer a very short reply. 0.74. What is the ratio of the Imports(as % of merchandise exports) in Norway in 1975 to that in 1976?
Your answer should be very brief. 0.39. What is the ratio of the Imports(as % of merchandise exports) in Zambia in 1975 to that in 1976?
Provide a short and direct response. 0.88. What is the ratio of the Imports(as % of merchandise exports) of Ecuador in 1975 to that in 1977?
Your answer should be very brief. 2.34. What is the ratio of the Imports(as % of merchandise exports) of Mali in 1975 to that in 1977?
Give a very brief answer. 0.59. What is the ratio of the Imports(as % of merchandise exports) in Norway in 1975 to that in 1977?
Make the answer very short. 0.39. What is the ratio of the Imports(as % of merchandise exports) in Zambia in 1975 to that in 1977?
Your answer should be very brief. 0.89. What is the ratio of the Imports(as % of merchandise exports) in Ecuador in 1976 to that in 1977?
Provide a short and direct response. 1.34. What is the ratio of the Imports(as % of merchandise exports) in Mali in 1976 to that in 1977?
Give a very brief answer. 0.8. What is the ratio of the Imports(as % of merchandise exports) in Norway in 1976 to that in 1977?
Offer a terse response. 1.01. What is the ratio of the Imports(as % of merchandise exports) in Zambia in 1976 to that in 1977?
Keep it short and to the point. 1.01. What is the difference between the highest and the second highest Imports(as % of merchandise exports) of Ecuador?
Make the answer very short. 9.21. What is the difference between the highest and the second highest Imports(as % of merchandise exports) of Mali?
Your answer should be compact. 3.59. What is the difference between the highest and the second highest Imports(as % of merchandise exports) of Norway?
Offer a very short reply. 0.11. What is the difference between the highest and the second highest Imports(as % of merchandise exports) in Zambia?
Offer a terse response. 0.2. What is the difference between the highest and the lowest Imports(as % of merchandise exports) of Ecuador?
Your response must be concise. 16.72. What is the difference between the highest and the lowest Imports(as % of merchandise exports) of Mali?
Provide a succinct answer. 9.12. What is the difference between the highest and the lowest Imports(as % of merchandise exports) in Norway?
Your answer should be very brief. 7.26. What is the difference between the highest and the lowest Imports(as % of merchandise exports) in Zambia?
Your answer should be compact. 8.89. 